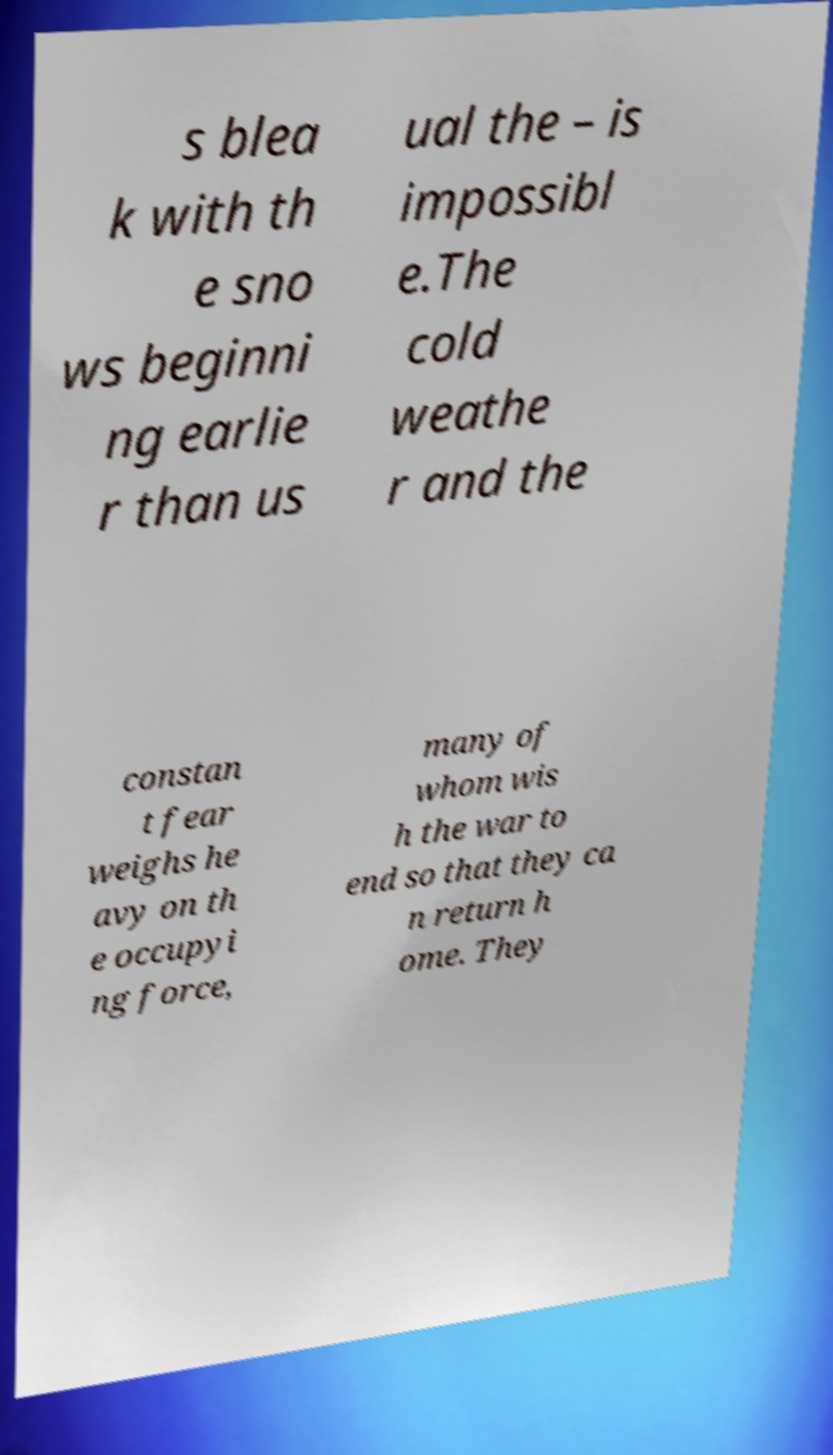I need the written content from this picture converted into text. Can you do that? s blea k with th e sno ws beginni ng earlie r than us ual the – is impossibl e.The cold weathe r and the constan t fear weighs he avy on th e occupyi ng force, many of whom wis h the war to end so that they ca n return h ome. They 